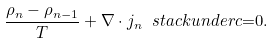Convert formula to latex. <formula><loc_0><loc_0><loc_500><loc_500>\frac { \rho _ { n } - \rho _ { n - 1 } } T + \nabla \cdot j _ { n } \ s t a c k u n d e r { c } { = } 0 .</formula> 